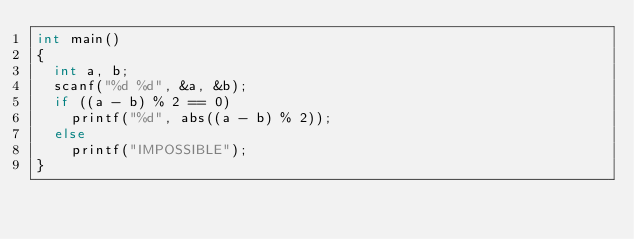Convert code to text. <code><loc_0><loc_0><loc_500><loc_500><_C_>int main()
{
  int a, b;
  scanf("%d %d", &a, &b);
  if ((a - b) % 2 == 0)
    printf("%d", abs((a - b) % 2));
  else
    printf("IMPOSSIBLE");
}</code> 